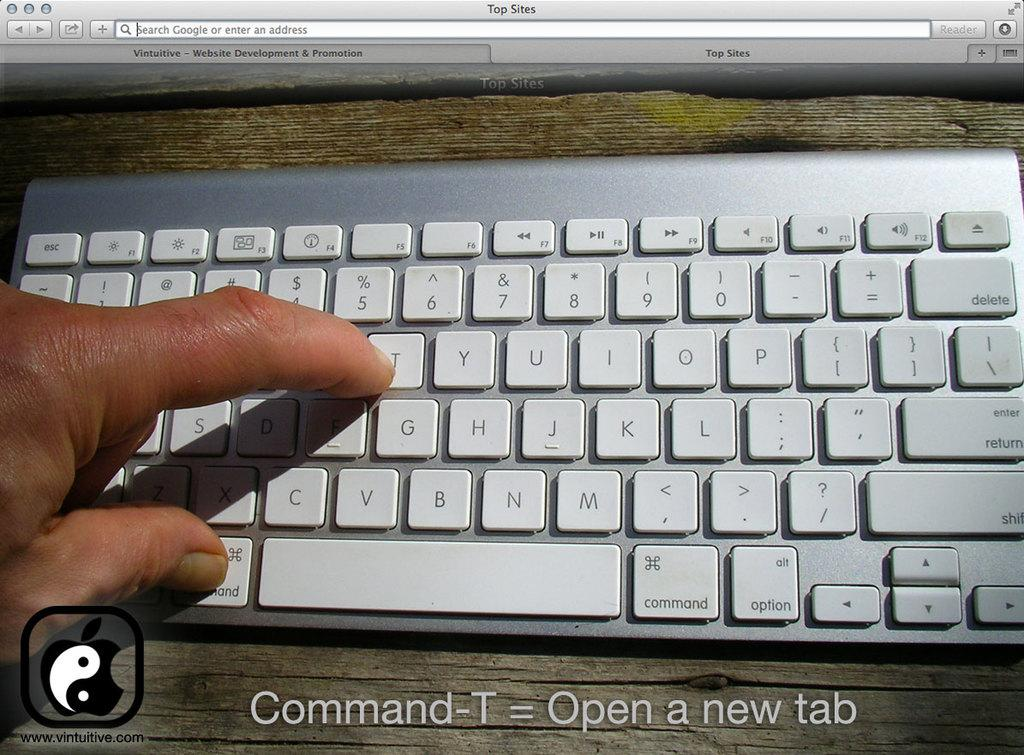<image>
Summarize the visual content of the image. a white keyboard is here, with a finger pointing to the T 